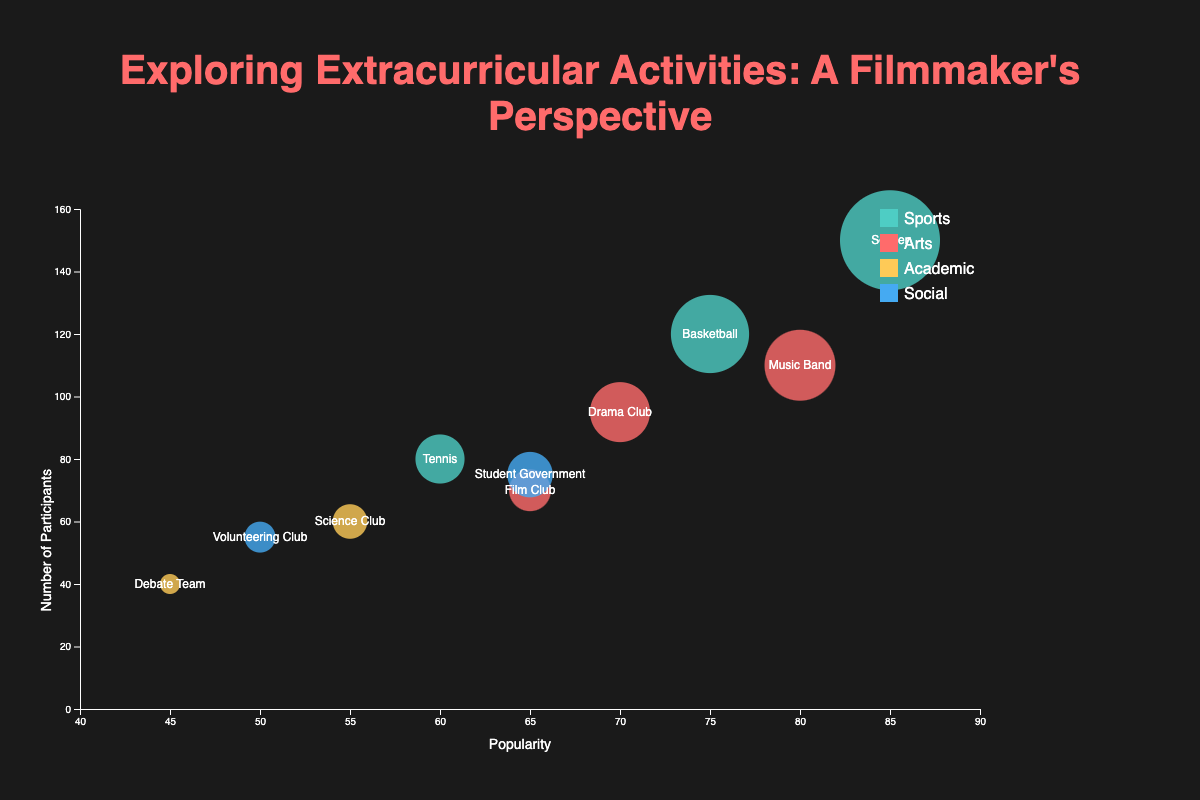What is the activity with the highest popularity? The activity with the highest popularity can be identified by looking at the bubble farthest to the right on the x-axis, which represents popularity. From the chart, this is Soccer with a popularity score of 85.
Answer: Soccer How many activities are plotted in the chart? Count the number of unique bubbles in the chart. Each bubble represents a distinct activity type. There are 10 unique activities.
Answer: 10 Which activity has the highest number of participants? The highest number of participants is represented by the bubble highest on the y-axis. The highest bubble is Soccer with 150 participants.
Answer: Soccer Compare the popularity of the Sports activities. Which one is the most and least popular? Looking at the x-axis positions of the bubbles within the ‘Sports’ category, we see that Soccer is the most popular with a score of 85, while Tennis is the least popular with a score of 60.
Answer: Most Popular: Soccer, Least Popular: Tennis Which activity has the smallest bubble, and what does it represent? The smallest bubble, indicating the least number of participants, is the Debate Team, which has 40 participants.
Answer: Debate Team What is the size range of the bubbles on the chart? The size of the bubbles is correlated with the number of participants. The smallest bubble has 40 participants (Debate Team), and the largest bubble has 150 participants (Soccer).
Answer: 40 to 150 How many activities belong to the 'Arts' category and what are they? Count the bubbles colored according to the 'Arts' category color and read their labels. There are three activities: Drama Club, Film Club, and Music Band.
Answer: 3; Drama Club, Film Club, Music Band What is the average popularity of the 'Social' activities? Add the popularity scores of the Social activities (Volunteering Club: 50, Student Government: 65) and divide by the number of activities. The result is (50 + 65) / 2 = 57.5.
Answer: 57.5 Which activities have a similar level of both popularity and participant count? By visually comparing the position and size of bubbles, the Drama Club and Film Club have similar locations with popularity around 65-70 and participant count around 70-95.
Answer: Drama Club and Film Club Which category has the most representation in terms of unique activities? Count the number of unique activities within each category. The 'Sports' category has three unique activities: Basketball, Soccer, and Tennis.
Answer: Sports 